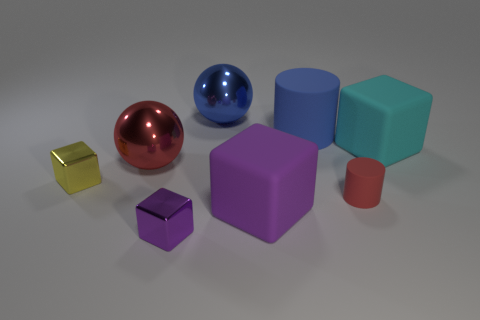Does the metallic cube right of the small yellow thing have the same color as the large rubber block that is left of the red cylinder? The metallic cube situated to the right of the small yellow object possesses a silver hue, which distinguishes it from the large purple rubber block located to the left of the red cylinder. Despite both items displaying reflective properties, their colors are not identical. 